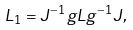Convert formula to latex. <formula><loc_0><loc_0><loc_500><loc_500>L _ { 1 } = J ^ { - 1 } g L g ^ { - 1 } J ,</formula> 